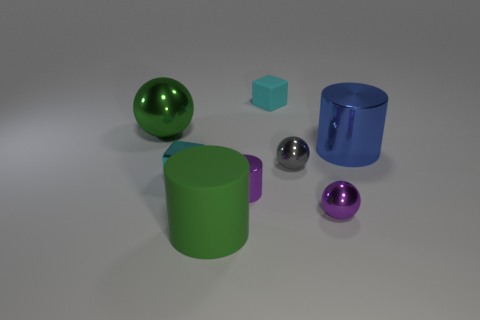Add 1 blue shiny things. How many objects exist? 9 Subtract all cubes. How many objects are left? 6 Subtract all blue things. Subtract all big rubber objects. How many objects are left? 6 Add 8 cyan metallic blocks. How many cyan metallic blocks are left? 9 Add 1 small purple metal balls. How many small purple metal balls exist? 2 Subtract 0 red cylinders. How many objects are left? 8 